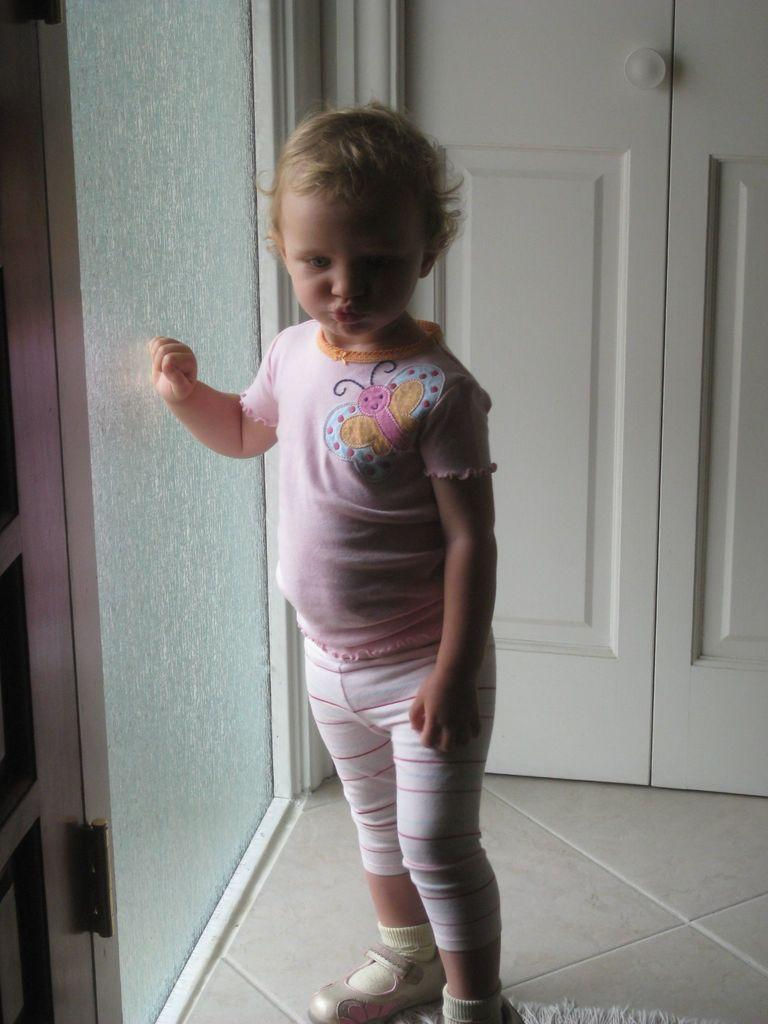What is the main subject of the image? There is a child in the image. Where is the child positioned in the image? The child is standing on the floor. What is located beside the child? There is a glass wall in the image beside the child. What is located behind the child? There is a white door in the image behind the child. What type of string can be seen hanging from the child's hand in the image? There is no string present in the image; the child's hands are not visible. 